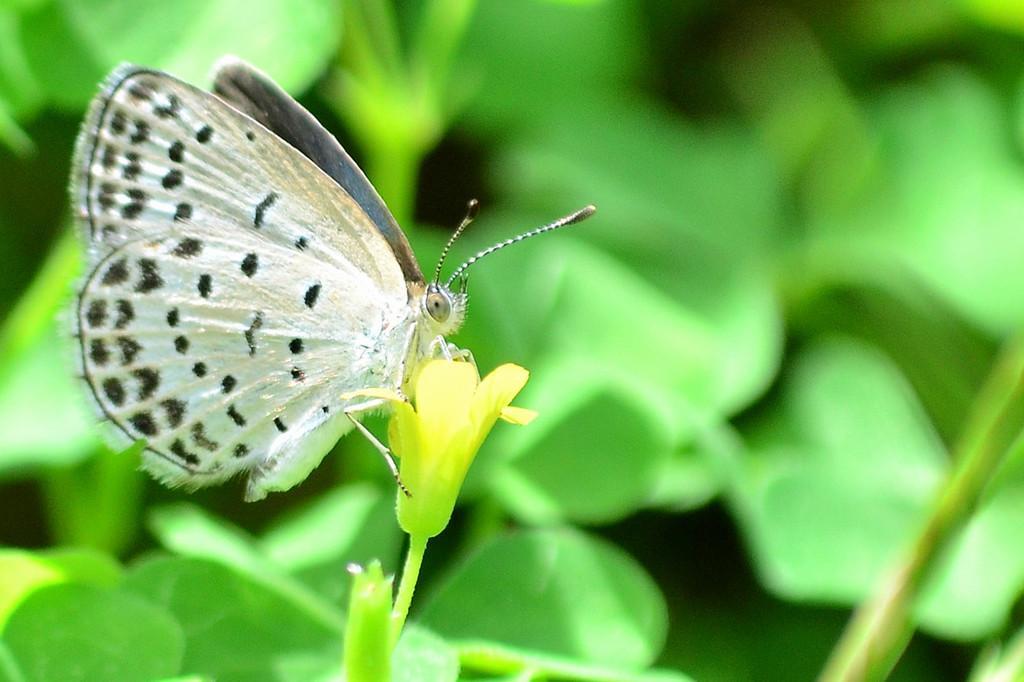In one or two sentences, can you explain what this image depicts? In this image we can see the butterfly on the flower. And we can see the green background. 